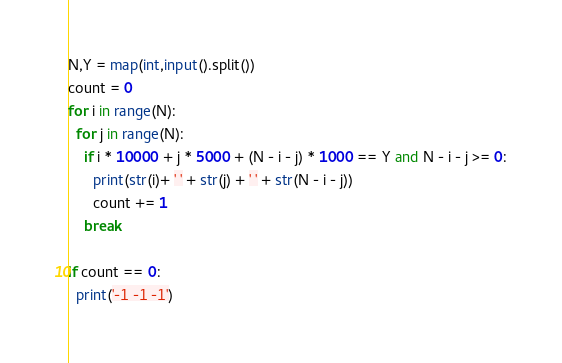<code> <loc_0><loc_0><loc_500><loc_500><_Python_>N,Y = map(int,input().split())
count = 0
for i in range(N):
  for j in range(N):
    if i * 10000 + j * 5000 + (N - i - j) * 1000 == Y and N - i - j >= 0:
      print(str(i)+ ' ' + str(j) + ' ' + str(N - i - j))
      count += 1
    break
      
if count == 0:
  print('-1 -1 -1')</code> 